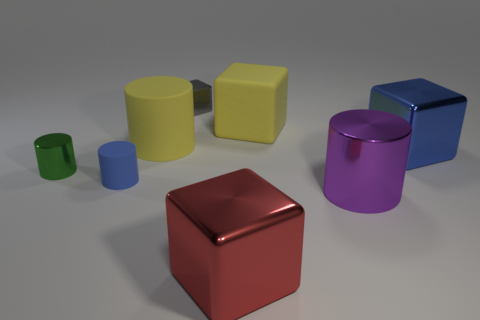What color is the other large thing that is the same shape as the purple metallic thing?
Your answer should be very brief. Yellow. The blue rubber cylinder is what size?
Provide a succinct answer. Small. What number of other gray blocks have the same size as the rubber block?
Provide a succinct answer. 0. Is the large matte cylinder the same color as the big matte cube?
Your answer should be compact. Yes. Does the large yellow thing left of the large red metal thing have the same material as the blue object that is to the right of the tiny gray metal object?
Your response must be concise. No. Is the number of big rubber cylinders greater than the number of yellow things?
Your answer should be compact. No. Is there anything else that has the same color as the large rubber block?
Offer a terse response. Yes. Is the small green cylinder made of the same material as the small blue cylinder?
Make the answer very short. No. Is the number of blue cubes less than the number of small cyan rubber spheres?
Provide a short and direct response. No. Is the green object the same shape as the big red object?
Make the answer very short. No. 